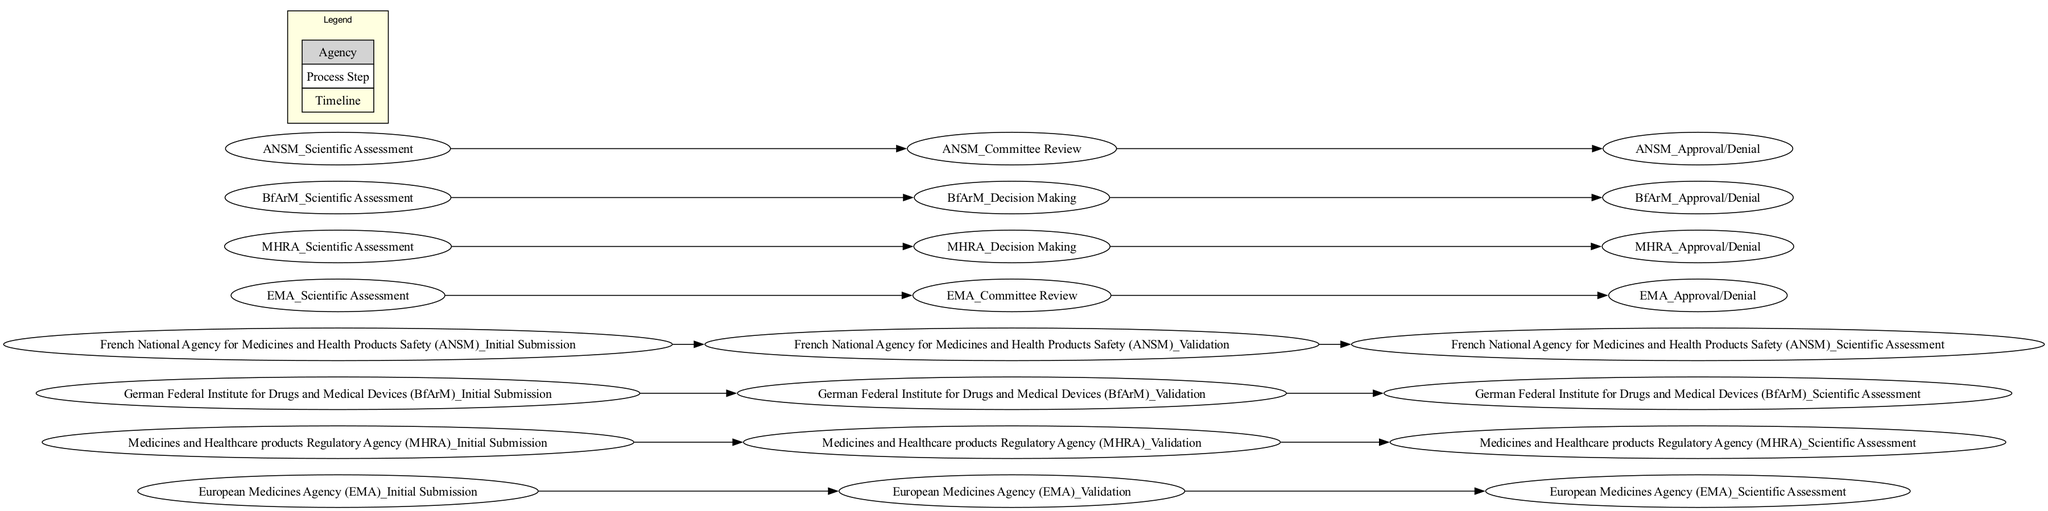What are the required steps for drug approval according to the EMA? The initial steps include Initial Submission, Validation, Scientific Assessment, Committee Review, and Approval/Denial. These are sequentially arranged in the swimlane diagram for the EMA lane.
Answer: Initial Submission, Validation, Scientific Assessment, Committee Review, Approval/Denial How many agencies are involved in the drug approval process? The swimlane diagram lists four agencies: EMA, MHRA, BfArM, and ANSM, each represented by a lane. This can be counted directly from the lanes shown.
Answer: Four What is the timeline for Scientific Assessment by the MHRA? The timeline indicated for the Scientific Assessment node in the MHRA lane is from Week 4 to Week 26, as shown in the swimlane diagram.
Answer: Week 4-26 Which agency has the longest duration for the Scientific Assessment phase? By comparing the timelines of the Scientific Assessment across different agencies, EMA and ANSM both take from Week 4 to Week 28, which is longer than MHRA's and BfArM's durations.
Answer: EMA and ANSM What is the relationship between the Committee Review process and Approval/Denial for the EMA? The swimlane diagram indicates an edge from Committee Review to Approval/Denial specifically for the EMA lane, implying that the Committee Review step leads directly to the final Approval/Denial step for EMA.
Answer: Leads to Which agency's Approval/Denial occurs the earliest? Analyzing the timelines, the MHRA completes the Approval/Denial phase in Week 31, which is earlier than both EMA and ANSM scheduled in Week 33.
Answer: MHRA How many weeks does the Validation phase take across all agencies? The Validation phase according to the diagram lasts from Week 2 to Week 3, which spans 2 weeks. This duration applies uniformly to all represented agencies.
Answer: 2 weeks Which agency's processes share the same timeline for the Initial Submission? The swimlane diagram shows that all four agencies (EMA, MHRA, BfArM, ANSM) have the Initial Submission step occurring in Week 1, indicating that their processes align at this initial stage.
Answer: All agencies Explain the flow from Scientific Assessment to Approval/Denial for BfArM. The flow can be traced starting from the Scientific Assessment phase, moving to Decision Making, and finally leading to Approval/Denial. The edges in BfArM lane illustrate that both the Scientific Assessment and Decision Making subsequently direct towards the Approval/Denial step.
Answer: Scientific Assessment → Decision Making → Approval/Denial 